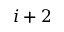<formula> <loc_0><loc_0><loc_500><loc_500>i + 2</formula> 